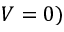Convert formula to latex. <formula><loc_0><loc_0><loc_500><loc_500>V = 0 )</formula> 